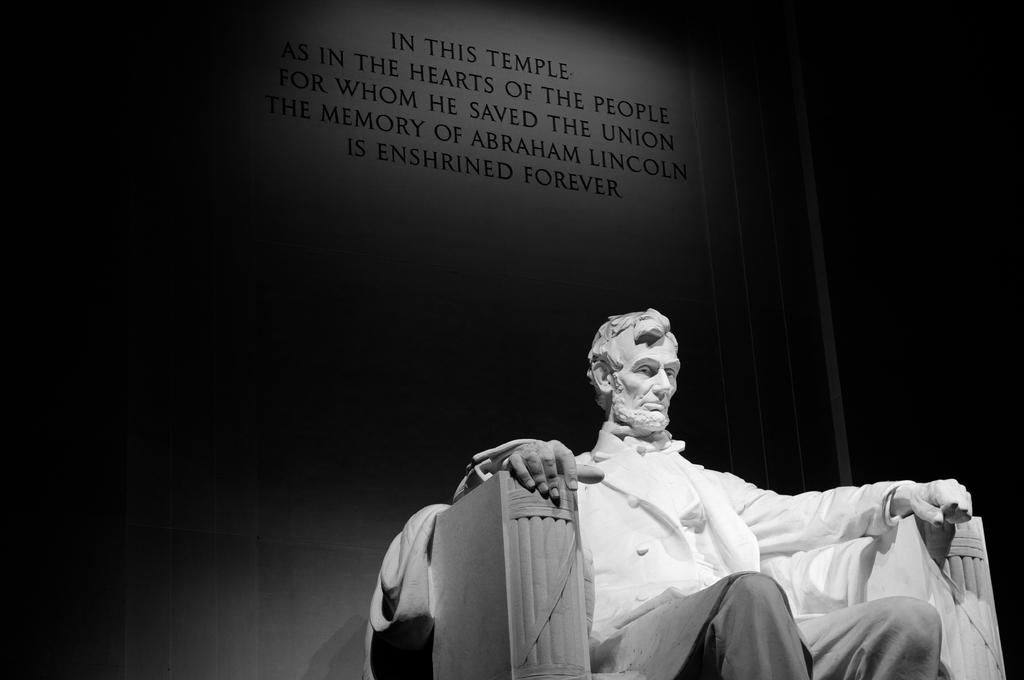What is the color scheme of the image? The image is black and white. What can be seen in the foreground of the image? There is a statue of a person sitting on a chair in the image. What is present in the background of the image? There is text written on a platform in the background of the image. Can you see any attractions at the seashore in the image? There is no seashore or attraction present in the image; it features a black and white statue of a person sitting on a chair with text written on a platform in the background. 